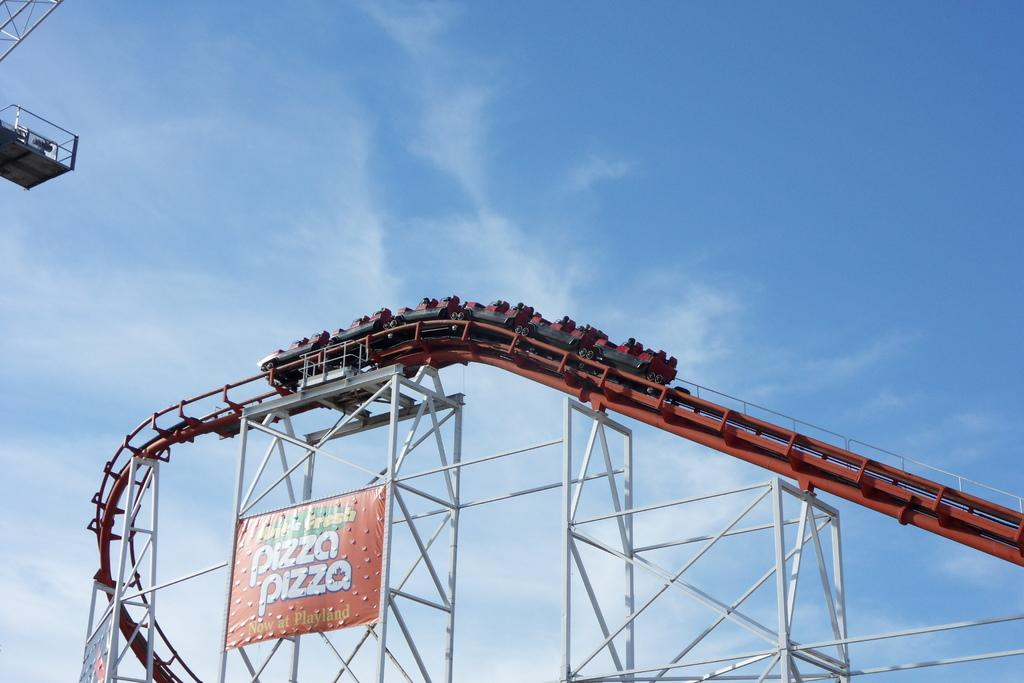<image>
Share a concise interpretation of the image provided. a rollercoaster that is running over a sign that says 'pizza pizza' 